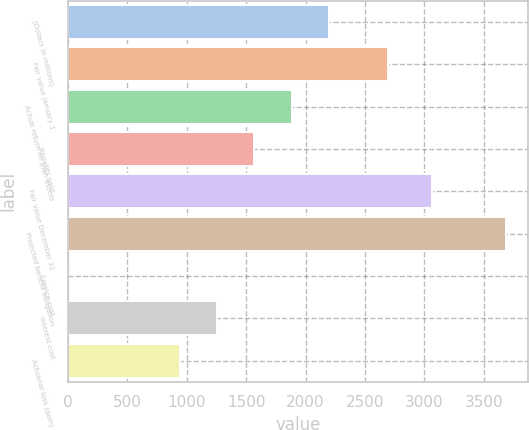Convert chart to OTSL. <chart><loc_0><loc_0><loc_500><loc_500><bar_chart><fcel>(Dollars in millions)<fcel>Fair value January 1<fcel>Actual return on plan assets<fcel>Benefits paid<fcel>Fair value December 31<fcel>Projected benefit obligation<fcel>Service cost<fcel>Interest cost<fcel>Actuarial loss (gain)<nl><fcel>2196.8<fcel>2689<fcel>1883.4<fcel>1570<fcel>3061<fcel>3687.8<fcel>3<fcel>1256.6<fcel>943.2<nl></chart> 